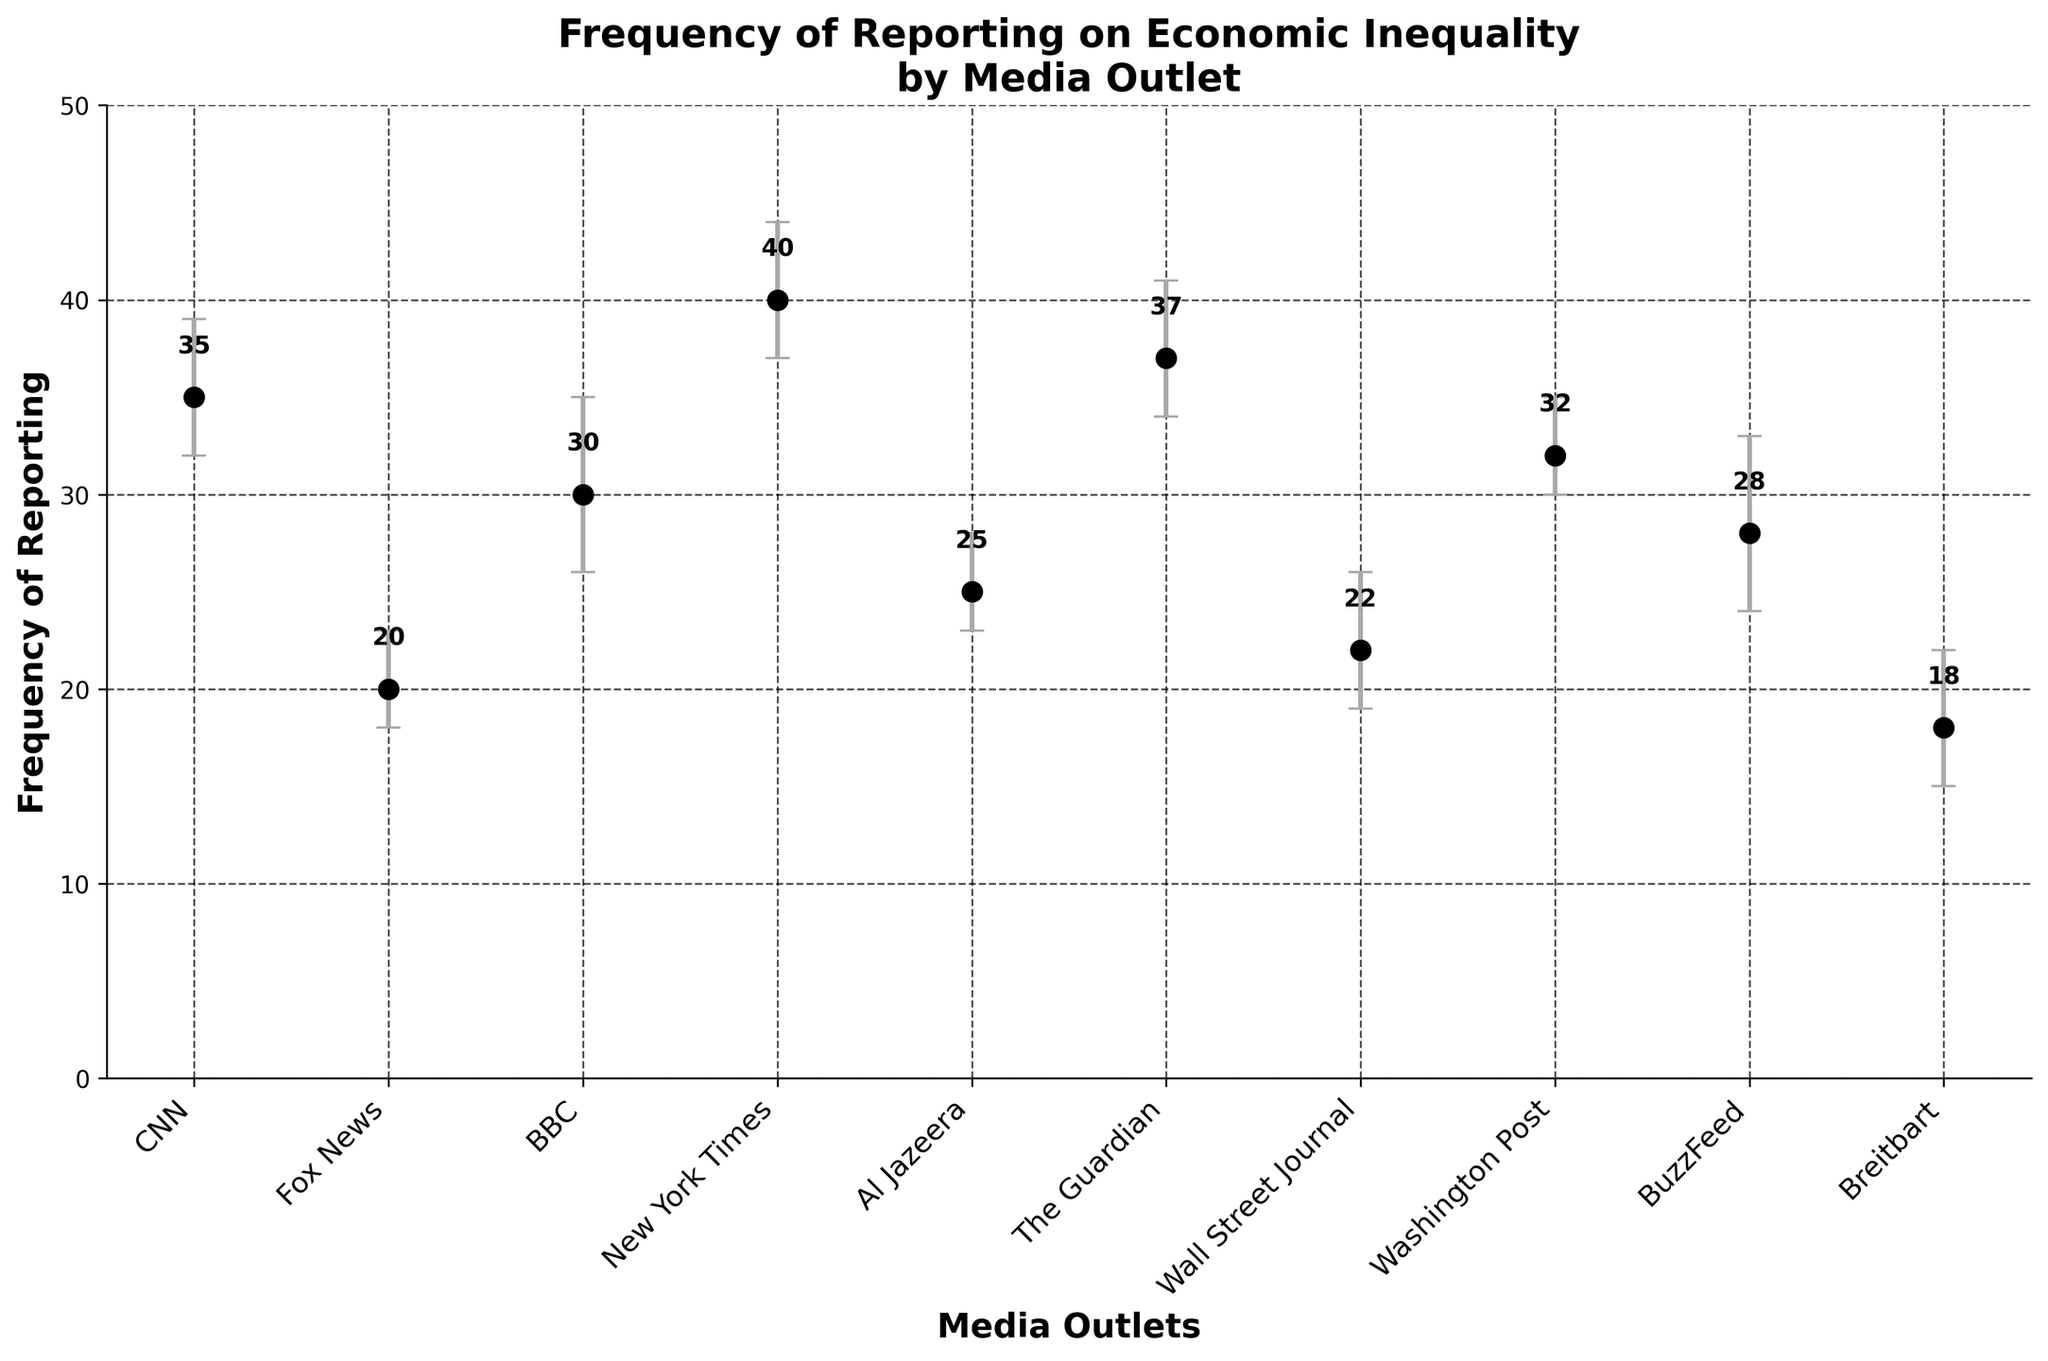What's the title of the figure? The title of the figure is located at the top and it provides a summary of what the figure is about.
Answer: Frequency of Reporting on Economic Inequality by Media Outlet How many media outlets are represented in the figure? The number of media outlets can be determined by counting the x-axis tick labels.
Answer: 10 Which media outlet reports the most frequently on economic inequality? The media outlet with the highest frequency value (y-axis) will be the one that reports the most.
Answer: New York Times What is the frequency of reporting for Fox News? The data point for Fox News is identified by locating it on the x-axis and reading its corresponding y-axis value.
Answer: 20 Which media outlet has the largest sampling error range, and what is that range? To find this, compare the error bars for each media outlet, and the largest range is found by subtracting the lower error value from the upper error value.
Answer: BuzzFeed; 9 What is the average frequency of reporting across all media outlets? Calculate the average by summing all frequencies and dividing by the number of outlets: (35 + 20 + 30 + 40 + 25 + 37 + 22 + 32 + 28 + 18) / 10.
Answer: 28.7 Which media outlet has the smallest lower sampling error? Find the smallest value in the "Sampling Error Lower" column.
Answer: Fox News and Al Jazeera, both have 2 How does the reporting frequency of The Guardian compare to CNN? Look at the y-axis values for both media outlets and compare them directly.
Answer: The Guardian reports slightly more frequently than CNN Is there any media outlet with a lower reporting frequency than Breitbart? Compare all y-axis values and identify any that lie below the frequency of Breitbart.
Answer: No What's the total range of frequencies reported across all media outlets in the figure? Subtract the smallest frequency value from the largest frequency value: 40 (New York Times) - 18 (Breitbart).
Answer: 22 